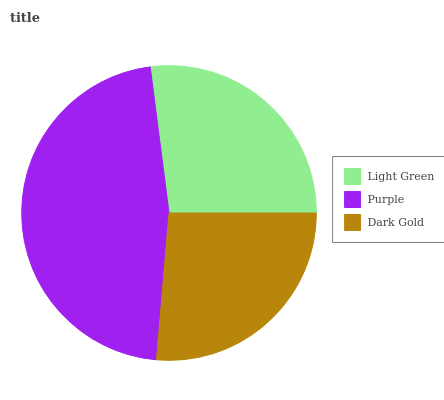Is Dark Gold the minimum?
Answer yes or no. Yes. Is Purple the maximum?
Answer yes or no. Yes. Is Purple the minimum?
Answer yes or no. No. Is Dark Gold the maximum?
Answer yes or no. No. Is Purple greater than Dark Gold?
Answer yes or no. Yes. Is Dark Gold less than Purple?
Answer yes or no. Yes. Is Dark Gold greater than Purple?
Answer yes or no. No. Is Purple less than Dark Gold?
Answer yes or no. No. Is Light Green the high median?
Answer yes or no. Yes. Is Light Green the low median?
Answer yes or no. Yes. Is Purple the high median?
Answer yes or no. No. Is Purple the low median?
Answer yes or no. No. 